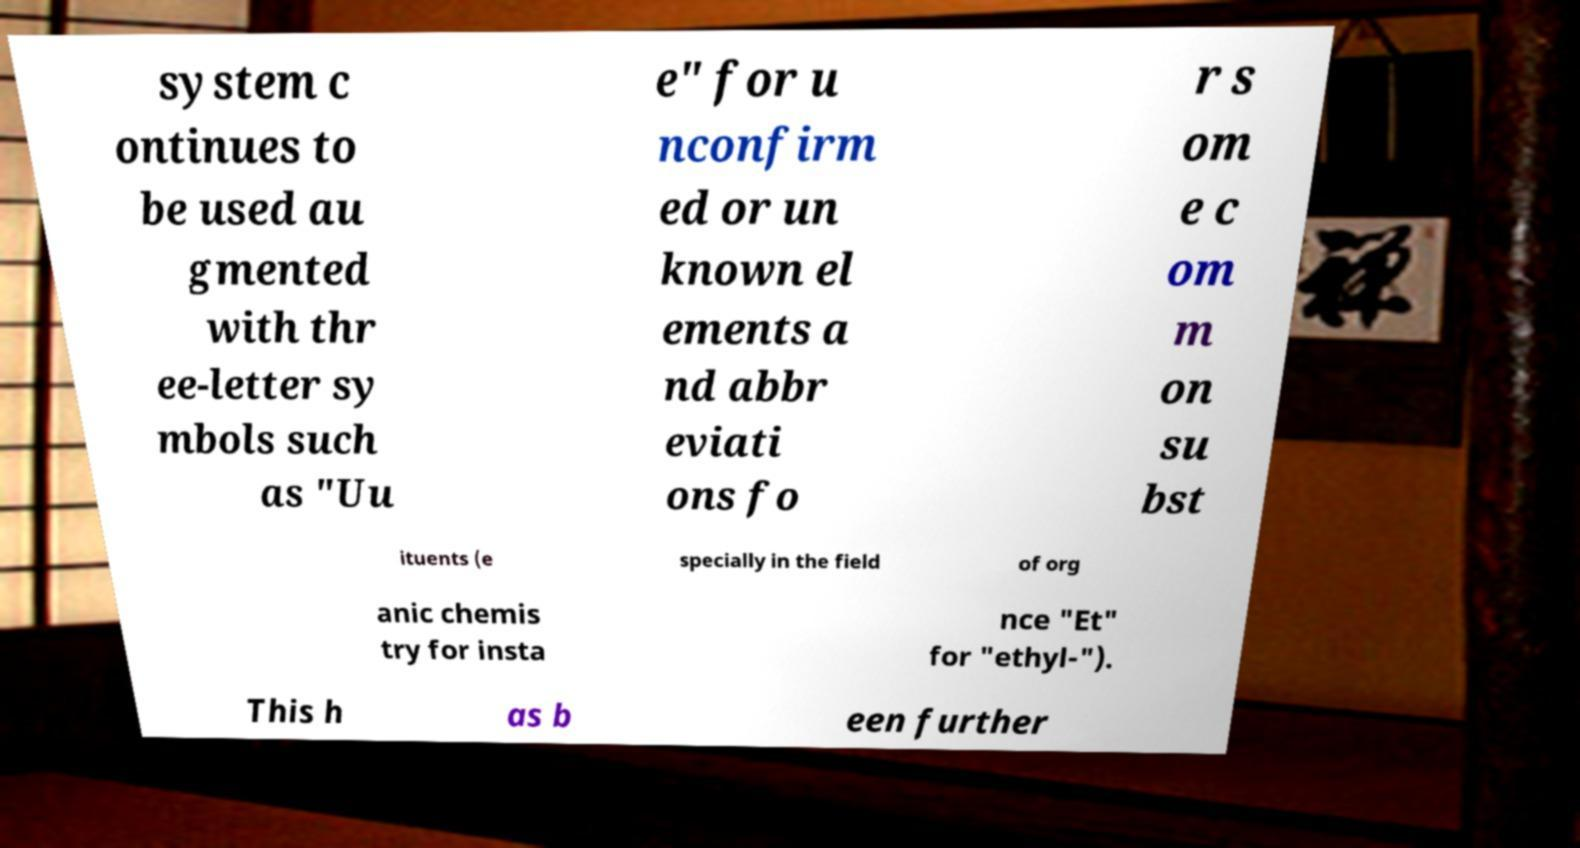What messages or text are displayed in this image? I need them in a readable, typed format. system c ontinues to be used au gmented with thr ee-letter sy mbols such as "Uu e" for u nconfirm ed or un known el ements a nd abbr eviati ons fo r s om e c om m on su bst ituents (e specially in the field of org anic chemis try for insta nce "Et" for "ethyl-"). This h as b een further 